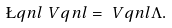Convert formula to latex. <formula><loc_0><loc_0><loc_500><loc_500>\L q n l \ V q n l = \ V q n l \Lambda .</formula> 